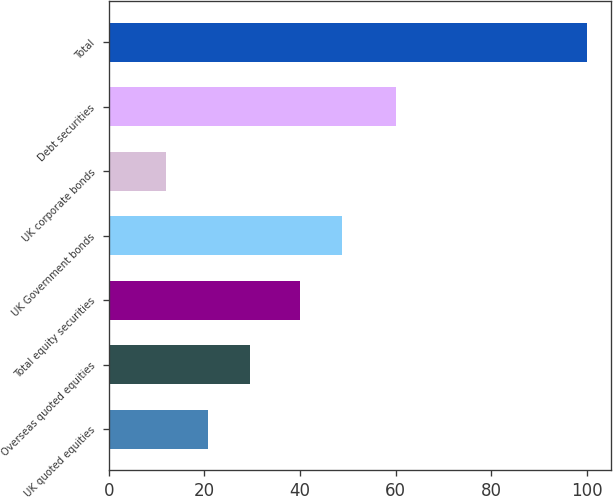<chart> <loc_0><loc_0><loc_500><loc_500><bar_chart><fcel>UK quoted equities<fcel>Overseas quoted equities<fcel>Total equity securities<fcel>UK Government bonds<fcel>UK corporate bonds<fcel>Debt securities<fcel>Total<nl><fcel>20.8<fcel>29.6<fcel>40<fcel>48.8<fcel>12<fcel>60<fcel>100<nl></chart> 